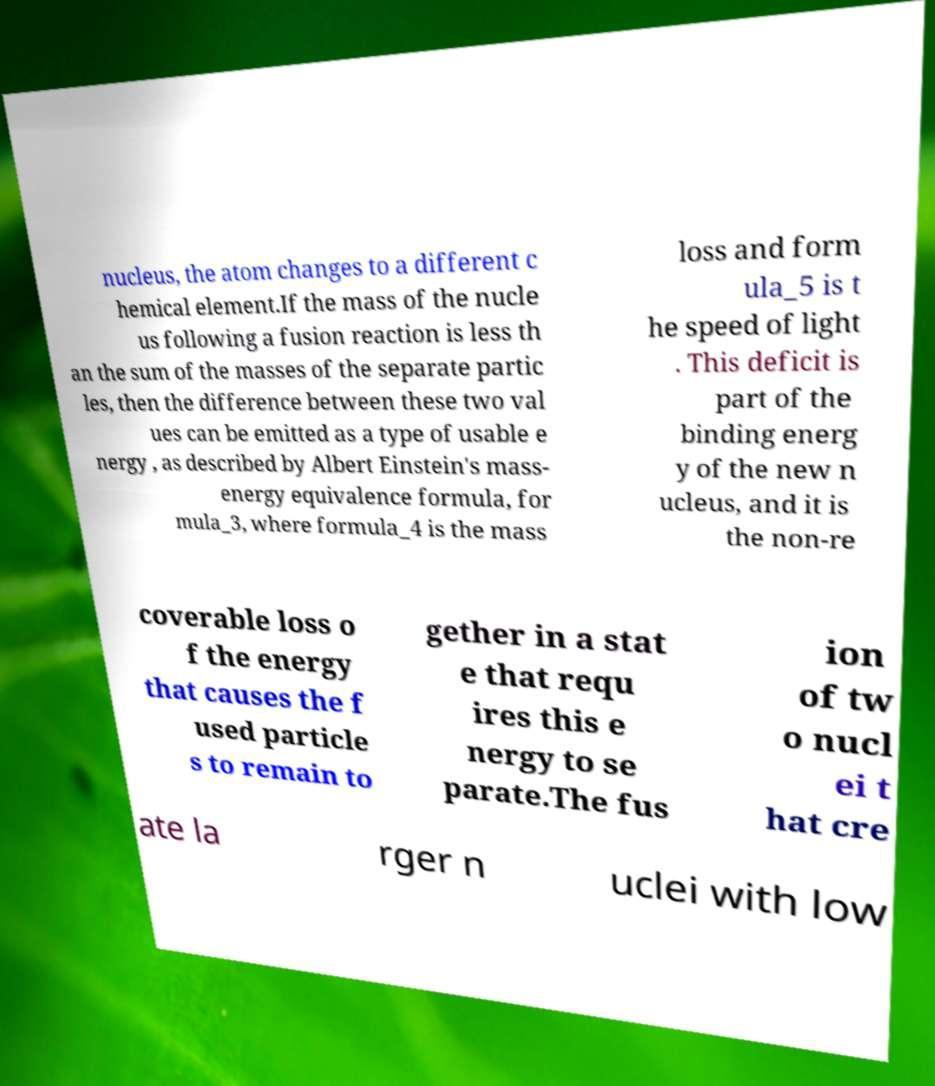Can you read and provide the text displayed in the image?This photo seems to have some interesting text. Can you extract and type it out for me? nucleus, the atom changes to a different c hemical element.If the mass of the nucle us following a fusion reaction is less th an the sum of the masses of the separate partic les, then the difference between these two val ues can be emitted as a type of usable e nergy , as described by Albert Einstein's mass- energy equivalence formula, for mula_3, where formula_4 is the mass loss and form ula_5 is t he speed of light . This deficit is part of the binding energ y of the new n ucleus, and it is the non-re coverable loss o f the energy that causes the f used particle s to remain to gether in a stat e that requ ires this e nergy to se parate.The fus ion of tw o nucl ei t hat cre ate la rger n uclei with low 